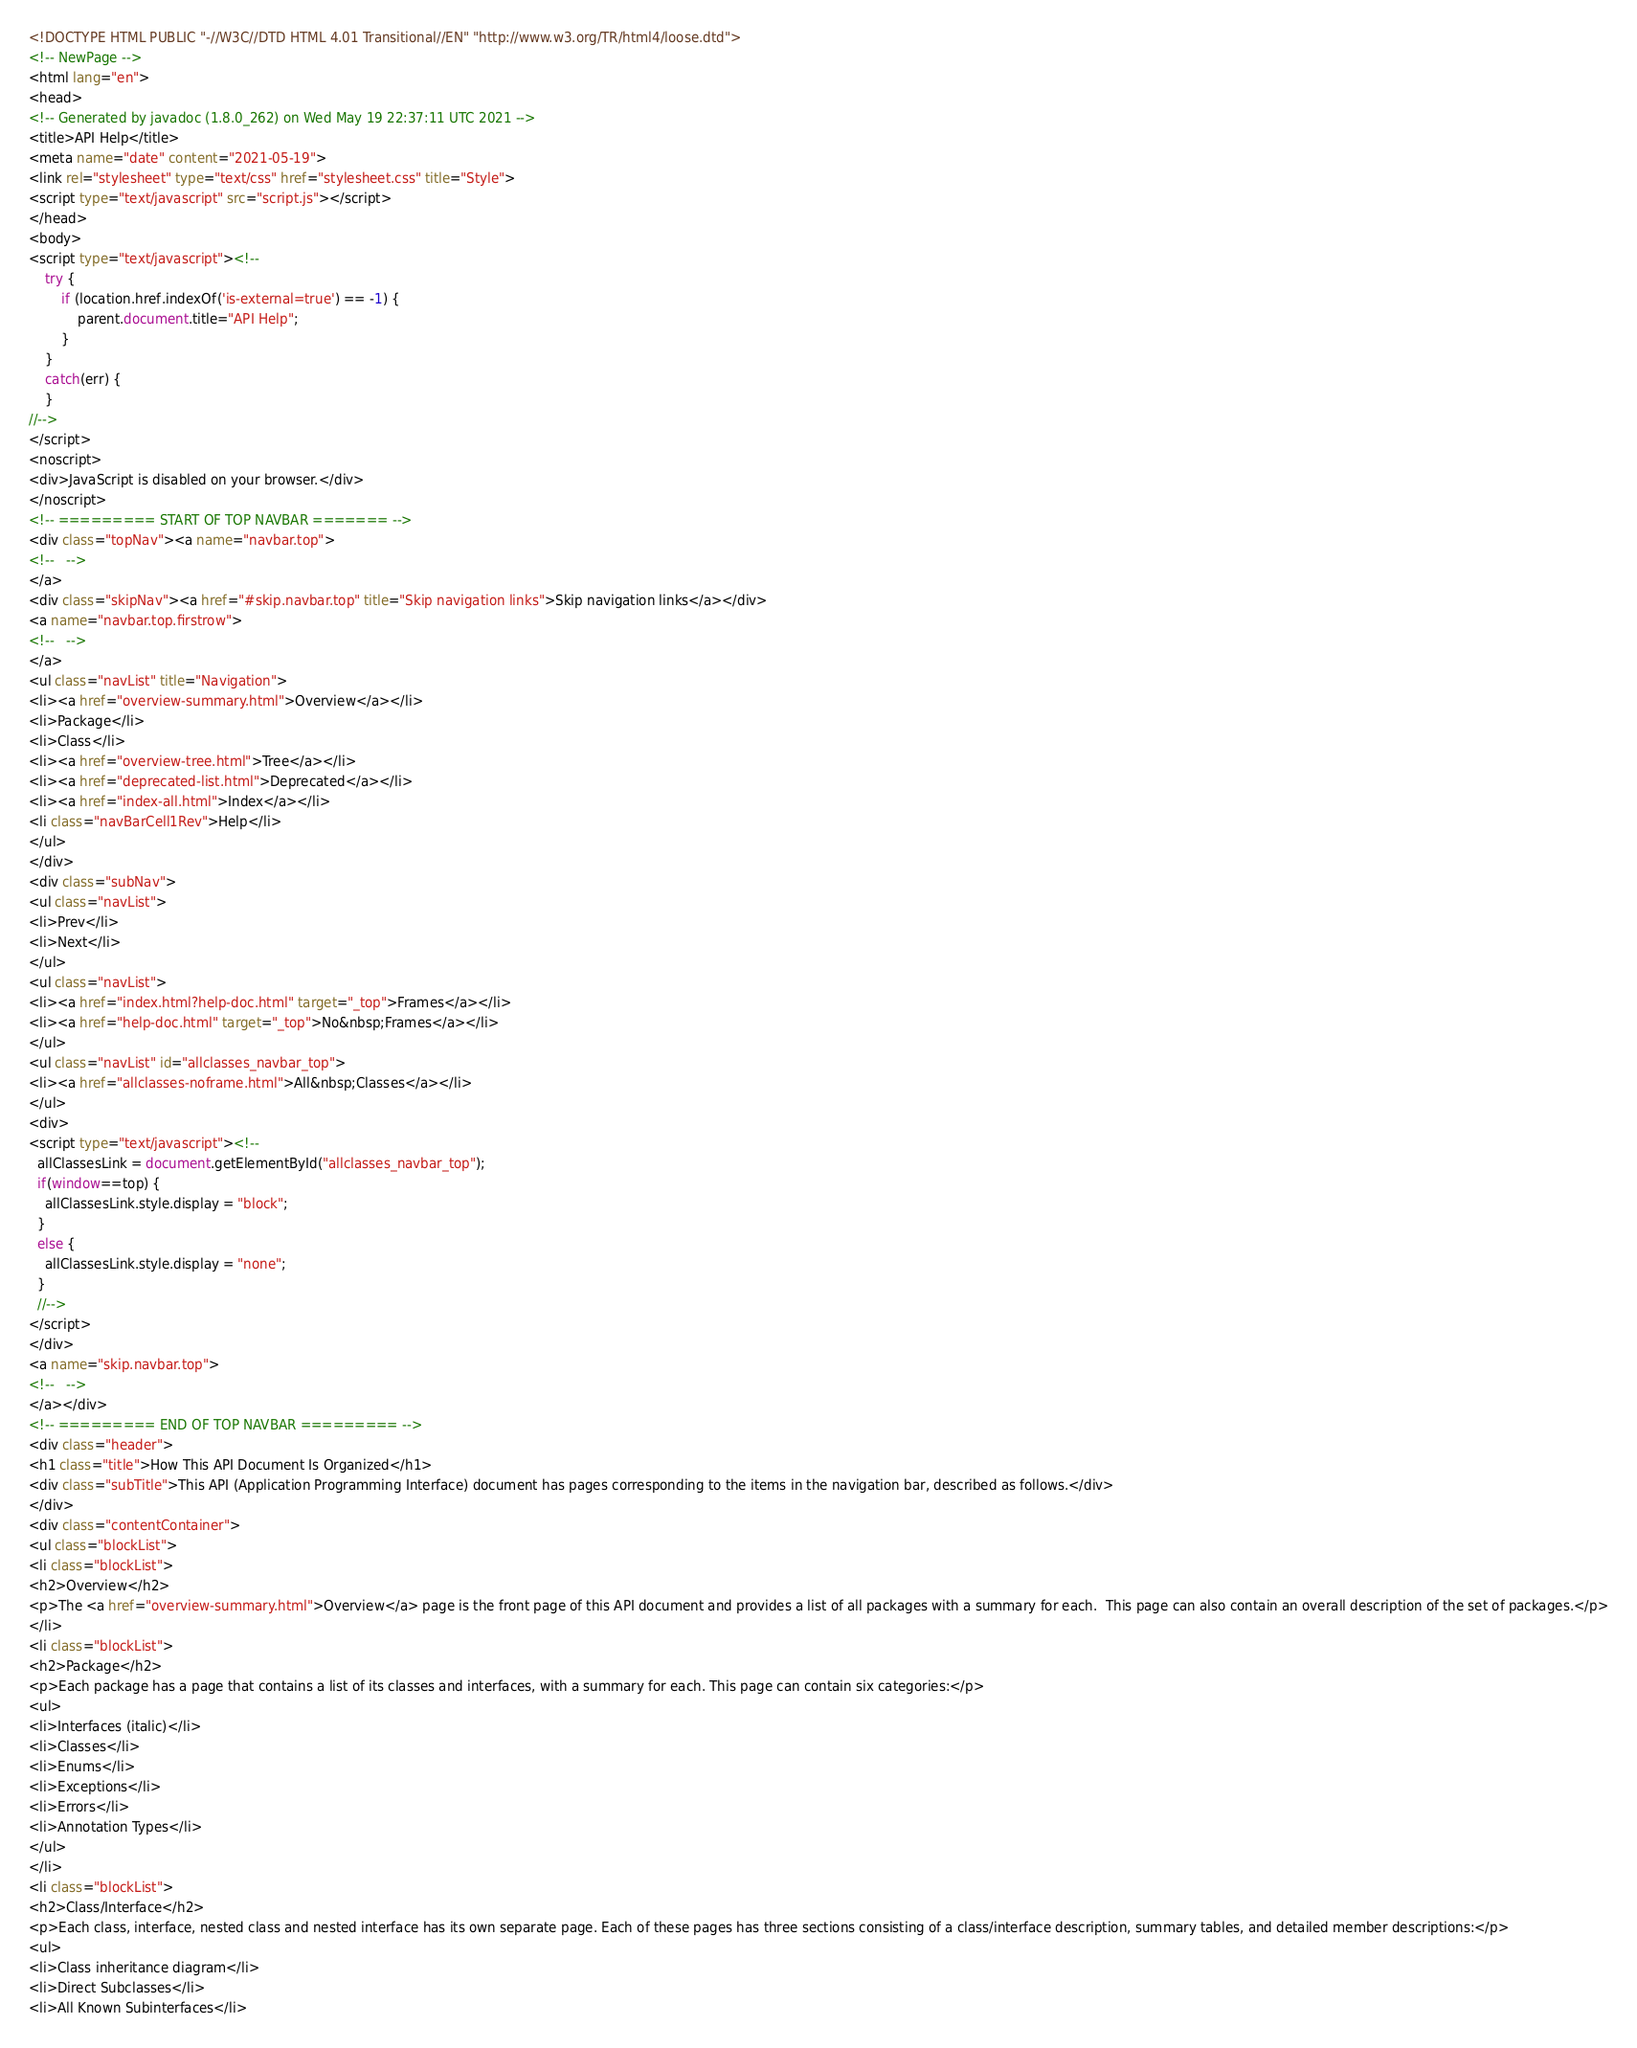Convert code to text. <code><loc_0><loc_0><loc_500><loc_500><_HTML_><!DOCTYPE HTML PUBLIC "-//W3C//DTD HTML 4.01 Transitional//EN" "http://www.w3.org/TR/html4/loose.dtd">
<!-- NewPage -->
<html lang="en">
<head>
<!-- Generated by javadoc (1.8.0_262) on Wed May 19 22:37:11 UTC 2021 -->
<title>API Help</title>
<meta name="date" content="2021-05-19">
<link rel="stylesheet" type="text/css" href="stylesheet.css" title="Style">
<script type="text/javascript" src="script.js"></script>
</head>
<body>
<script type="text/javascript"><!--
    try {
        if (location.href.indexOf('is-external=true') == -1) {
            parent.document.title="API Help";
        }
    }
    catch(err) {
    }
//-->
</script>
<noscript>
<div>JavaScript is disabled on your browser.</div>
</noscript>
<!-- ========= START OF TOP NAVBAR ======= -->
<div class="topNav"><a name="navbar.top">
<!--   -->
</a>
<div class="skipNav"><a href="#skip.navbar.top" title="Skip navigation links">Skip navigation links</a></div>
<a name="navbar.top.firstrow">
<!--   -->
</a>
<ul class="navList" title="Navigation">
<li><a href="overview-summary.html">Overview</a></li>
<li>Package</li>
<li>Class</li>
<li><a href="overview-tree.html">Tree</a></li>
<li><a href="deprecated-list.html">Deprecated</a></li>
<li><a href="index-all.html">Index</a></li>
<li class="navBarCell1Rev">Help</li>
</ul>
</div>
<div class="subNav">
<ul class="navList">
<li>Prev</li>
<li>Next</li>
</ul>
<ul class="navList">
<li><a href="index.html?help-doc.html" target="_top">Frames</a></li>
<li><a href="help-doc.html" target="_top">No&nbsp;Frames</a></li>
</ul>
<ul class="navList" id="allclasses_navbar_top">
<li><a href="allclasses-noframe.html">All&nbsp;Classes</a></li>
</ul>
<div>
<script type="text/javascript"><!--
  allClassesLink = document.getElementById("allclasses_navbar_top");
  if(window==top) {
    allClassesLink.style.display = "block";
  }
  else {
    allClassesLink.style.display = "none";
  }
  //-->
</script>
</div>
<a name="skip.navbar.top">
<!--   -->
</a></div>
<!-- ========= END OF TOP NAVBAR ========= -->
<div class="header">
<h1 class="title">How This API Document Is Organized</h1>
<div class="subTitle">This API (Application Programming Interface) document has pages corresponding to the items in the navigation bar, described as follows.</div>
</div>
<div class="contentContainer">
<ul class="blockList">
<li class="blockList">
<h2>Overview</h2>
<p>The <a href="overview-summary.html">Overview</a> page is the front page of this API document and provides a list of all packages with a summary for each.  This page can also contain an overall description of the set of packages.</p>
</li>
<li class="blockList">
<h2>Package</h2>
<p>Each package has a page that contains a list of its classes and interfaces, with a summary for each. This page can contain six categories:</p>
<ul>
<li>Interfaces (italic)</li>
<li>Classes</li>
<li>Enums</li>
<li>Exceptions</li>
<li>Errors</li>
<li>Annotation Types</li>
</ul>
</li>
<li class="blockList">
<h2>Class/Interface</h2>
<p>Each class, interface, nested class and nested interface has its own separate page. Each of these pages has three sections consisting of a class/interface description, summary tables, and detailed member descriptions:</p>
<ul>
<li>Class inheritance diagram</li>
<li>Direct Subclasses</li>
<li>All Known Subinterfaces</li></code> 